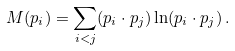Convert formula to latex. <formula><loc_0><loc_0><loc_500><loc_500>M ( p _ { i } ) = \sum _ { i < j } ( p _ { i } \cdot p _ { j } ) \ln ( p _ { i } \cdot p _ { j } ) \, .</formula> 